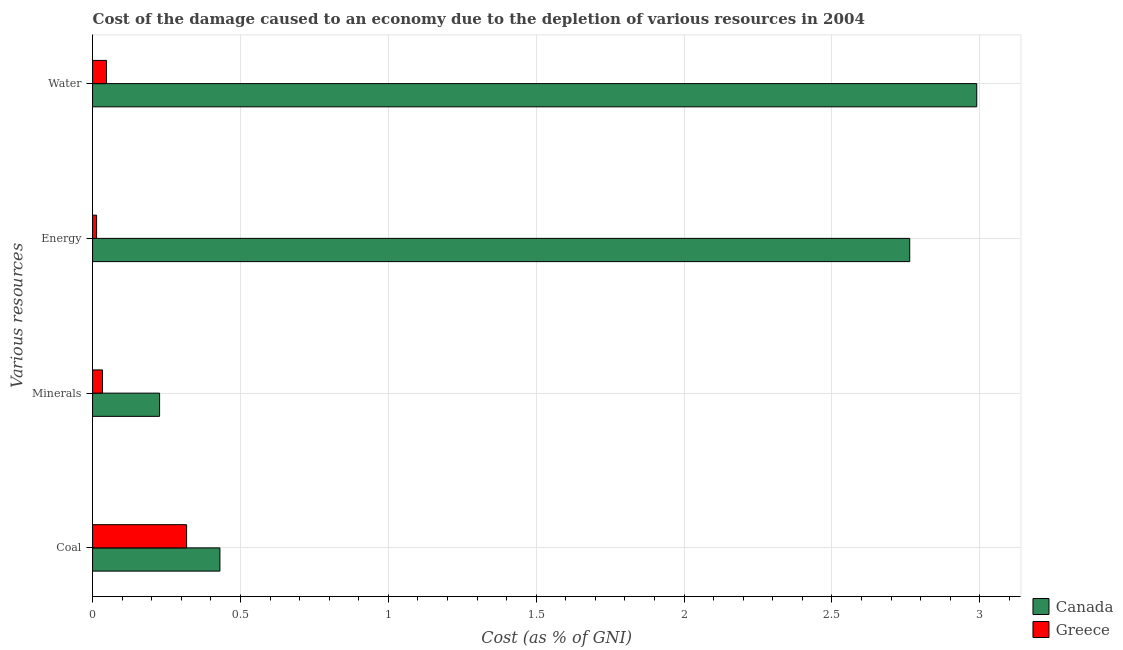How many bars are there on the 1st tick from the top?
Your answer should be compact. 2. How many bars are there on the 3rd tick from the bottom?
Keep it short and to the point. 2. What is the label of the 4th group of bars from the top?
Provide a succinct answer. Coal. What is the cost of damage due to depletion of energy in Canada?
Provide a short and direct response. 2.76. Across all countries, what is the maximum cost of damage due to depletion of minerals?
Your answer should be compact. 0.23. Across all countries, what is the minimum cost of damage due to depletion of energy?
Make the answer very short. 0.01. In which country was the cost of damage due to depletion of energy maximum?
Make the answer very short. Canada. In which country was the cost of damage due to depletion of energy minimum?
Offer a terse response. Greece. What is the total cost of damage due to depletion of water in the graph?
Your answer should be very brief. 3.04. What is the difference between the cost of damage due to depletion of coal in Canada and that in Greece?
Provide a succinct answer. 0.11. What is the difference between the cost of damage due to depletion of minerals in Canada and the cost of damage due to depletion of water in Greece?
Give a very brief answer. 0.18. What is the average cost of damage due to depletion of minerals per country?
Give a very brief answer. 0.13. What is the difference between the cost of damage due to depletion of minerals and cost of damage due to depletion of water in Greece?
Your response must be concise. -0.01. What is the ratio of the cost of damage due to depletion of coal in Canada to that in Greece?
Keep it short and to the point. 1.35. Is the cost of damage due to depletion of coal in Greece less than that in Canada?
Provide a short and direct response. Yes. What is the difference between the highest and the second highest cost of damage due to depletion of minerals?
Provide a short and direct response. 0.19. What is the difference between the highest and the lowest cost of damage due to depletion of minerals?
Your response must be concise. 0.19. Is it the case that in every country, the sum of the cost of damage due to depletion of energy and cost of damage due to depletion of coal is greater than the sum of cost of damage due to depletion of water and cost of damage due to depletion of minerals?
Make the answer very short. No. What does the 2nd bar from the bottom in Energy represents?
Your answer should be compact. Greece. Is it the case that in every country, the sum of the cost of damage due to depletion of coal and cost of damage due to depletion of minerals is greater than the cost of damage due to depletion of energy?
Give a very brief answer. No. How many bars are there?
Your answer should be compact. 8. Are all the bars in the graph horizontal?
Your answer should be compact. Yes. Does the graph contain grids?
Your answer should be very brief. Yes. Where does the legend appear in the graph?
Your answer should be compact. Bottom right. How many legend labels are there?
Your answer should be compact. 2. How are the legend labels stacked?
Offer a terse response. Vertical. What is the title of the graph?
Make the answer very short. Cost of the damage caused to an economy due to the depletion of various resources in 2004 . What is the label or title of the X-axis?
Your response must be concise. Cost (as % of GNI). What is the label or title of the Y-axis?
Give a very brief answer. Various resources. What is the Cost (as % of GNI) in Canada in Coal?
Make the answer very short. 0.43. What is the Cost (as % of GNI) of Greece in Coal?
Offer a very short reply. 0.32. What is the Cost (as % of GNI) in Canada in Minerals?
Provide a succinct answer. 0.23. What is the Cost (as % of GNI) of Greece in Minerals?
Keep it short and to the point. 0.03. What is the Cost (as % of GNI) in Canada in Energy?
Your answer should be compact. 2.76. What is the Cost (as % of GNI) of Greece in Energy?
Offer a terse response. 0.01. What is the Cost (as % of GNI) in Canada in Water?
Your answer should be compact. 2.99. What is the Cost (as % of GNI) of Greece in Water?
Your answer should be compact. 0.05. Across all Various resources, what is the maximum Cost (as % of GNI) of Canada?
Make the answer very short. 2.99. Across all Various resources, what is the maximum Cost (as % of GNI) in Greece?
Your answer should be compact. 0.32. Across all Various resources, what is the minimum Cost (as % of GNI) in Canada?
Make the answer very short. 0.23. Across all Various resources, what is the minimum Cost (as % of GNI) of Greece?
Offer a very short reply. 0.01. What is the total Cost (as % of GNI) of Canada in the graph?
Provide a succinct answer. 6.41. What is the total Cost (as % of GNI) of Greece in the graph?
Ensure brevity in your answer.  0.41. What is the difference between the Cost (as % of GNI) in Canada in Coal and that in Minerals?
Give a very brief answer. 0.2. What is the difference between the Cost (as % of GNI) in Greece in Coal and that in Minerals?
Offer a very short reply. 0.28. What is the difference between the Cost (as % of GNI) in Canada in Coal and that in Energy?
Provide a succinct answer. -2.33. What is the difference between the Cost (as % of GNI) in Greece in Coal and that in Energy?
Your answer should be compact. 0.3. What is the difference between the Cost (as % of GNI) in Canada in Coal and that in Water?
Your response must be concise. -2.56. What is the difference between the Cost (as % of GNI) of Greece in Coal and that in Water?
Keep it short and to the point. 0.27. What is the difference between the Cost (as % of GNI) of Canada in Minerals and that in Energy?
Your answer should be compact. -2.54. What is the difference between the Cost (as % of GNI) of Greece in Minerals and that in Energy?
Provide a short and direct response. 0.02. What is the difference between the Cost (as % of GNI) in Canada in Minerals and that in Water?
Provide a succinct answer. -2.76. What is the difference between the Cost (as % of GNI) in Greece in Minerals and that in Water?
Your response must be concise. -0.01. What is the difference between the Cost (as % of GNI) of Canada in Energy and that in Water?
Provide a short and direct response. -0.23. What is the difference between the Cost (as % of GNI) of Greece in Energy and that in Water?
Your answer should be compact. -0.03. What is the difference between the Cost (as % of GNI) in Canada in Coal and the Cost (as % of GNI) in Greece in Minerals?
Offer a very short reply. 0.4. What is the difference between the Cost (as % of GNI) of Canada in Coal and the Cost (as % of GNI) of Greece in Energy?
Give a very brief answer. 0.42. What is the difference between the Cost (as % of GNI) in Canada in Coal and the Cost (as % of GNI) in Greece in Water?
Offer a terse response. 0.38. What is the difference between the Cost (as % of GNI) of Canada in Minerals and the Cost (as % of GNI) of Greece in Energy?
Give a very brief answer. 0.21. What is the difference between the Cost (as % of GNI) in Canada in Minerals and the Cost (as % of GNI) in Greece in Water?
Give a very brief answer. 0.18. What is the difference between the Cost (as % of GNI) in Canada in Energy and the Cost (as % of GNI) in Greece in Water?
Offer a terse response. 2.72. What is the average Cost (as % of GNI) in Canada per Various resources?
Keep it short and to the point. 1.6. What is the average Cost (as % of GNI) of Greece per Various resources?
Ensure brevity in your answer.  0.1. What is the difference between the Cost (as % of GNI) in Canada and Cost (as % of GNI) in Greece in Coal?
Your answer should be compact. 0.11. What is the difference between the Cost (as % of GNI) of Canada and Cost (as % of GNI) of Greece in Minerals?
Offer a terse response. 0.19. What is the difference between the Cost (as % of GNI) of Canada and Cost (as % of GNI) of Greece in Energy?
Offer a terse response. 2.75. What is the difference between the Cost (as % of GNI) in Canada and Cost (as % of GNI) in Greece in Water?
Make the answer very short. 2.94. What is the ratio of the Cost (as % of GNI) of Canada in Coal to that in Minerals?
Ensure brevity in your answer.  1.9. What is the ratio of the Cost (as % of GNI) of Greece in Coal to that in Minerals?
Your answer should be compact. 9.45. What is the ratio of the Cost (as % of GNI) of Canada in Coal to that in Energy?
Keep it short and to the point. 0.16. What is the ratio of the Cost (as % of GNI) of Greece in Coal to that in Energy?
Offer a terse response. 23.37. What is the ratio of the Cost (as % of GNI) in Canada in Coal to that in Water?
Offer a very short reply. 0.14. What is the ratio of the Cost (as % of GNI) of Greece in Coal to that in Water?
Your response must be concise. 6.73. What is the ratio of the Cost (as % of GNI) in Canada in Minerals to that in Energy?
Offer a very short reply. 0.08. What is the ratio of the Cost (as % of GNI) of Greece in Minerals to that in Energy?
Your response must be concise. 2.47. What is the ratio of the Cost (as % of GNI) of Canada in Minerals to that in Water?
Provide a short and direct response. 0.08. What is the ratio of the Cost (as % of GNI) in Greece in Minerals to that in Water?
Provide a short and direct response. 0.71. What is the ratio of the Cost (as % of GNI) of Canada in Energy to that in Water?
Ensure brevity in your answer.  0.92. What is the ratio of the Cost (as % of GNI) in Greece in Energy to that in Water?
Give a very brief answer. 0.29. What is the difference between the highest and the second highest Cost (as % of GNI) in Canada?
Your response must be concise. 0.23. What is the difference between the highest and the second highest Cost (as % of GNI) in Greece?
Provide a short and direct response. 0.27. What is the difference between the highest and the lowest Cost (as % of GNI) in Canada?
Your answer should be very brief. 2.76. What is the difference between the highest and the lowest Cost (as % of GNI) of Greece?
Provide a short and direct response. 0.3. 